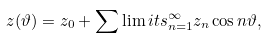<formula> <loc_0><loc_0><loc_500><loc_500>z ( \vartheta ) = z _ { 0 } + \sum \lim i t s _ { n = 1 } ^ { \infty } z _ { n } \cos { n \vartheta } ,</formula> 